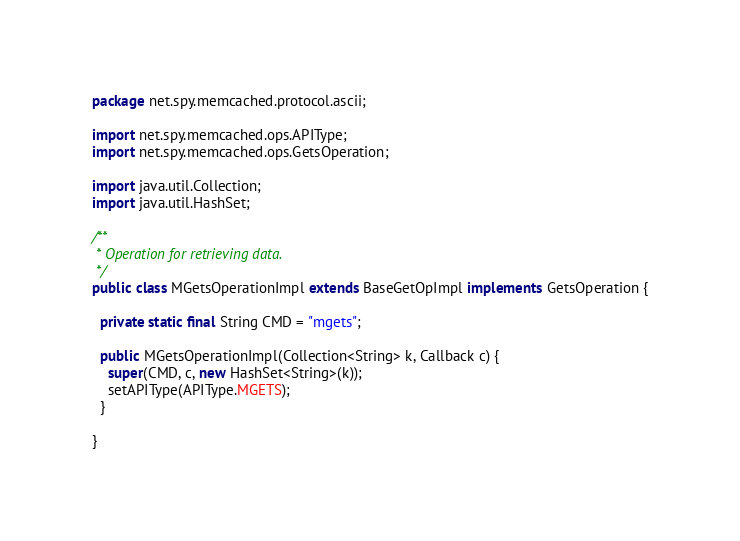Convert code to text. <code><loc_0><loc_0><loc_500><loc_500><_Java_>package net.spy.memcached.protocol.ascii;

import net.spy.memcached.ops.APIType;
import net.spy.memcached.ops.GetsOperation;

import java.util.Collection;
import java.util.HashSet;

/**
 * Operation for retrieving data.
 */
public class MGetsOperationImpl extends BaseGetOpImpl implements GetsOperation {

  private static final String CMD = "mgets";

  public MGetsOperationImpl(Collection<String> k, Callback c) {
    super(CMD, c, new HashSet<String>(k));
    setAPIType(APIType.MGETS);
  }

}
</code> 